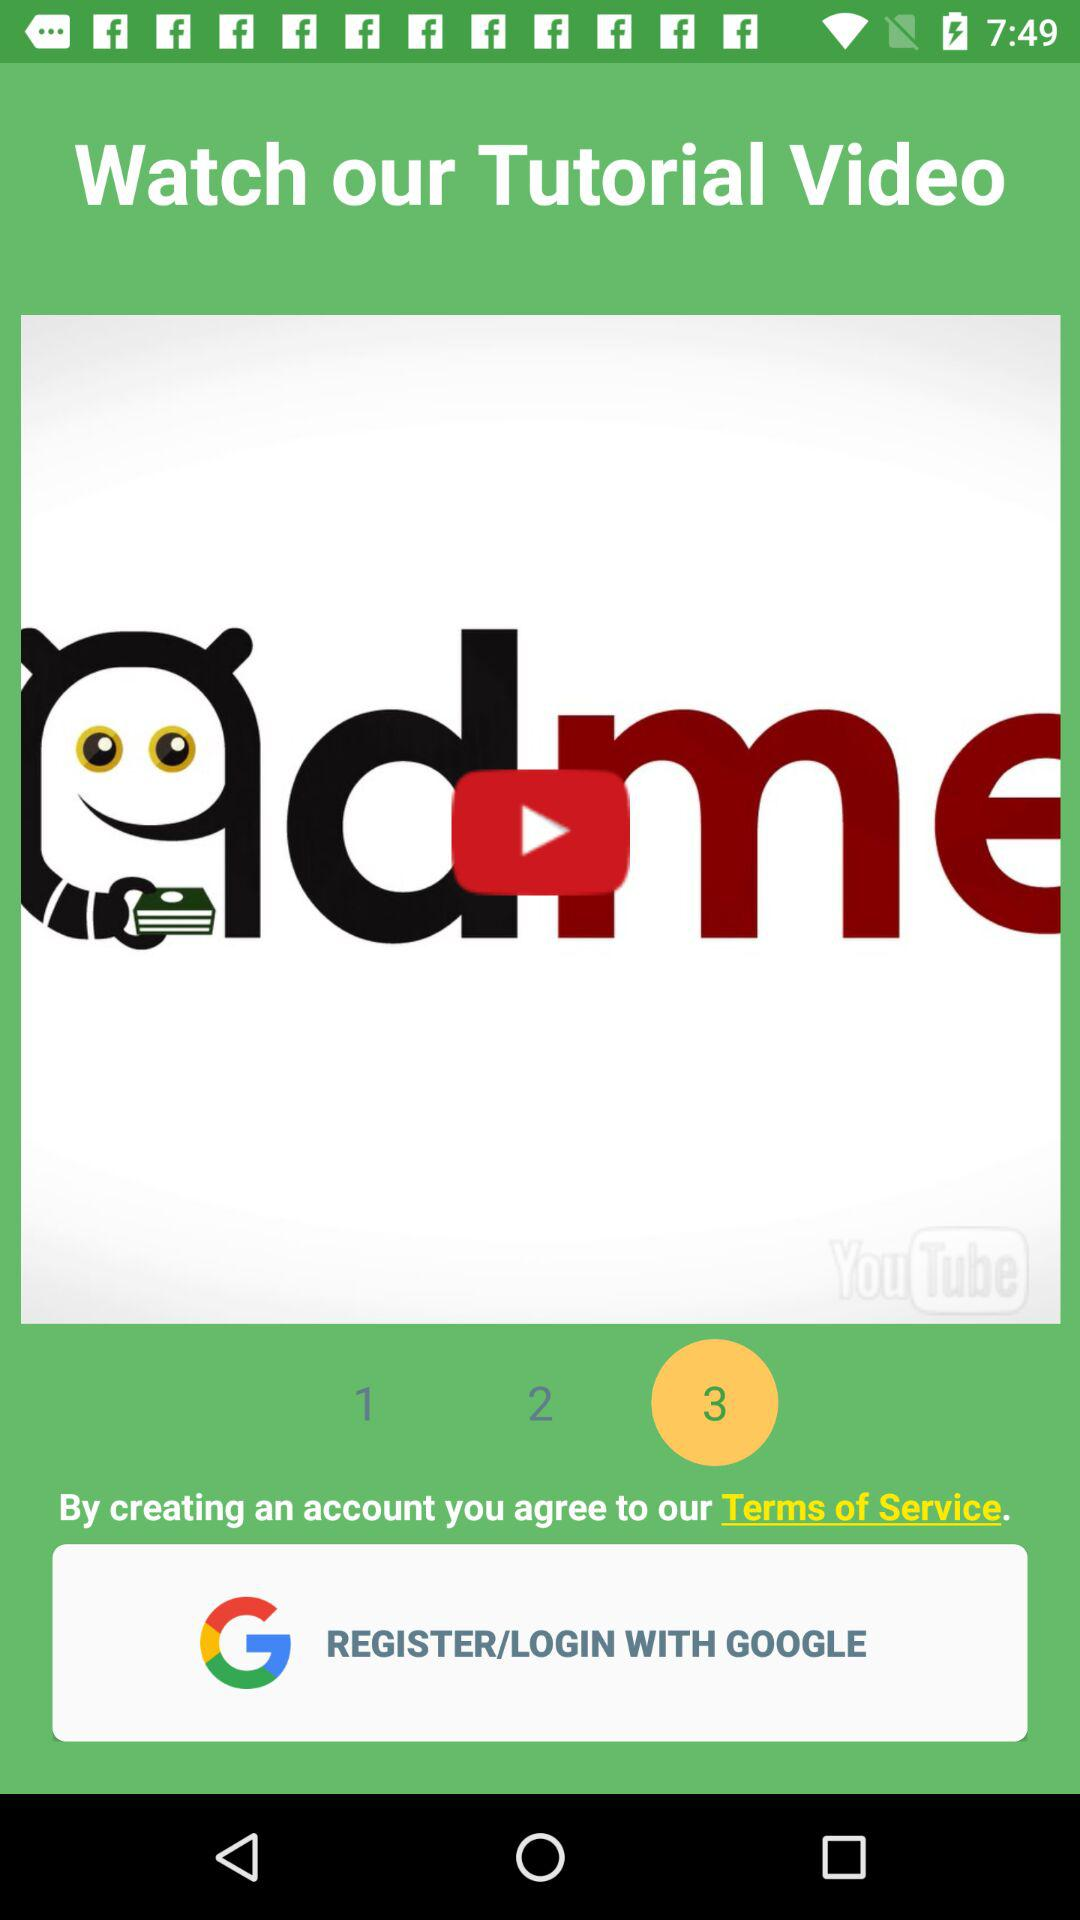What is the selected number? The selected number is 3. 